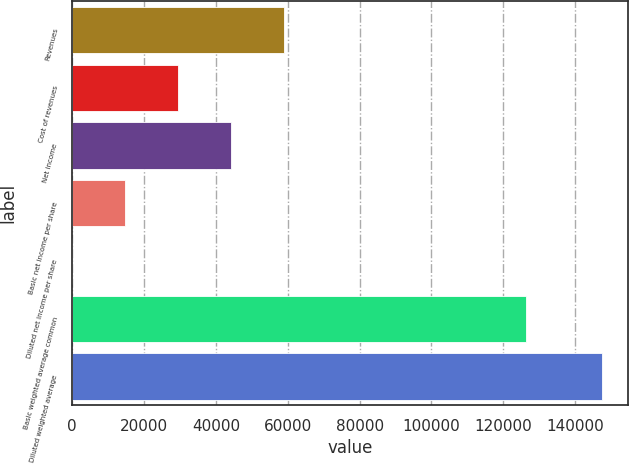Convert chart. <chart><loc_0><loc_0><loc_500><loc_500><bar_chart><fcel>Revenues<fcel>Cost of revenues<fcel>Net income<fcel>Basic net income per share<fcel>Diluted net income per share<fcel>Basic weighted average common<fcel>Diluted weighted average<nl><fcel>58922.5<fcel>29461.3<fcel>44191.9<fcel>14730.7<fcel>0.1<fcel>126261<fcel>147306<nl></chart> 